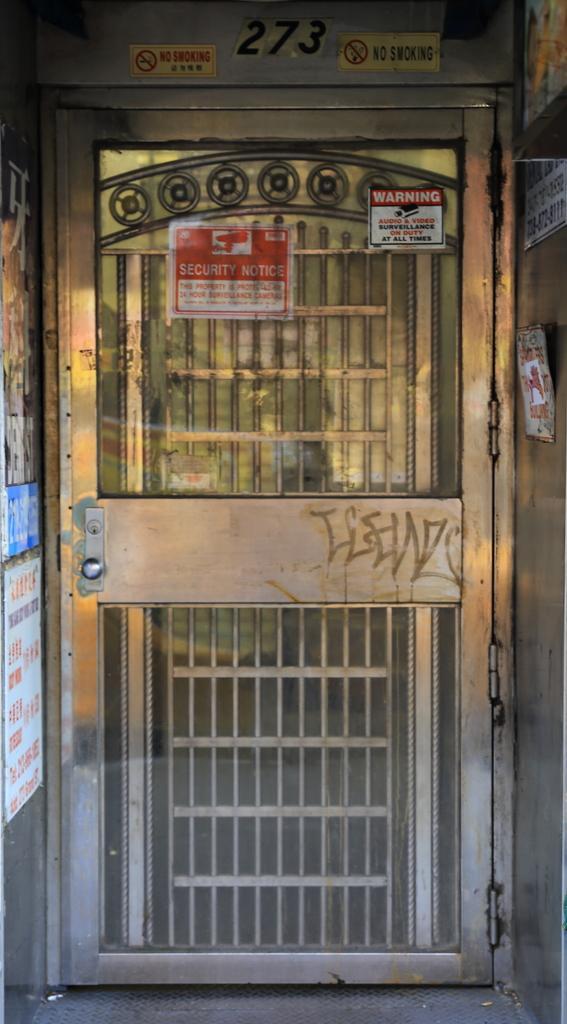Could you give a brief overview of what you see in this image? In this image I can see the door and I can see few boards attached to the board. On both sides of the door I can see few more boards. 